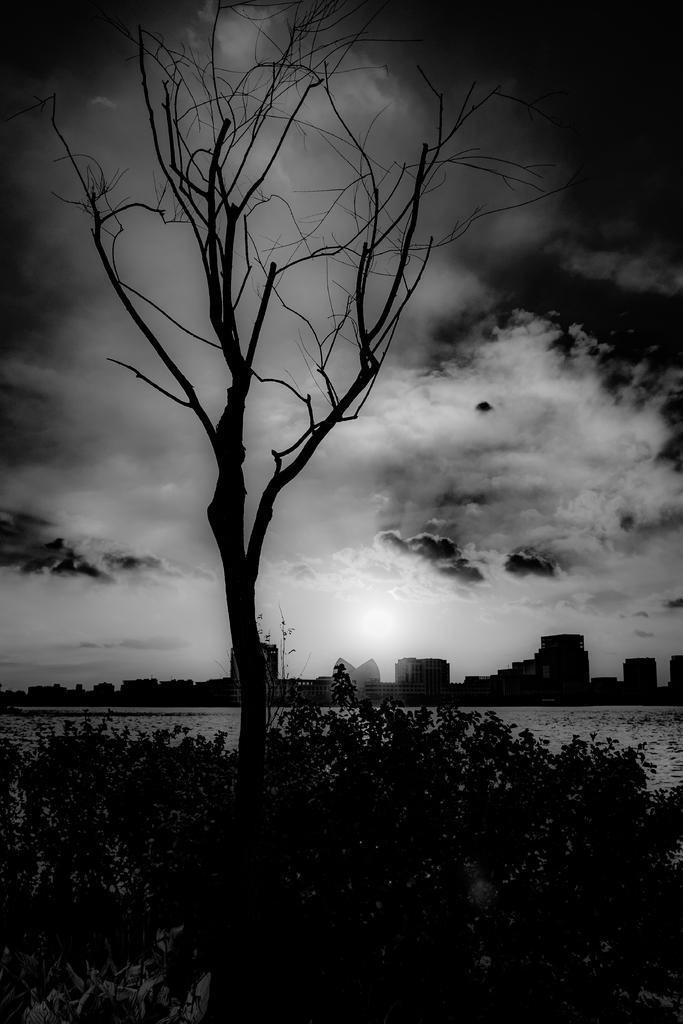Can you describe this image briefly? In this black and white picture there are plants and a tree. Behind them there is water. In the background there are buildings. At the top there is the sky. 